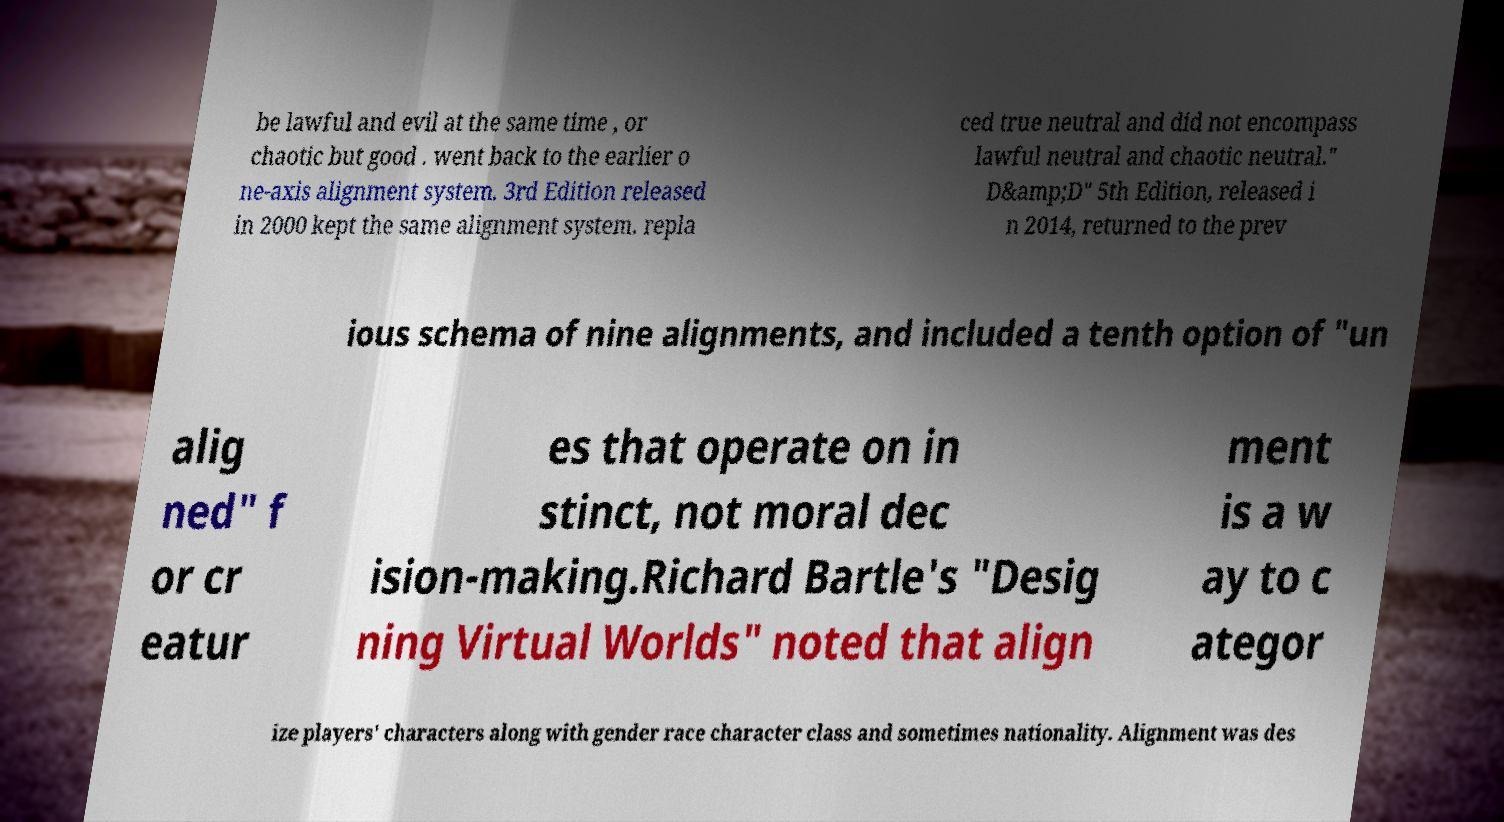Can you accurately transcribe the text from the provided image for me? be lawful and evil at the same time , or chaotic but good . went back to the earlier o ne-axis alignment system. 3rd Edition released in 2000 kept the same alignment system. repla ced true neutral and did not encompass lawful neutral and chaotic neutral." D&amp;D" 5th Edition, released i n 2014, returned to the prev ious schema of nine alignments, and included a tenth option of "un alig ned" f or cr eatur es that operate on in stinct, not moral dec ision-making.Richard Bartle's "Desig ning Virtual Worlds" noted that align ment is a w ay to c ategor ize players' characters along with gender race character class and sometimes nationality. Alignment was des 